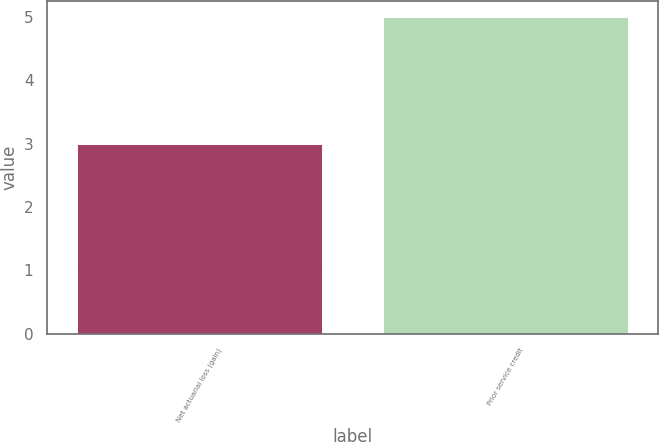<chart> <loc_0><loc_0><loc_500><loc_500><bar_chart><fcel>Net actuarial loss (gain)<fcel>Prior service credit<nl><fcel>3<fcel>5<nl></chart> 